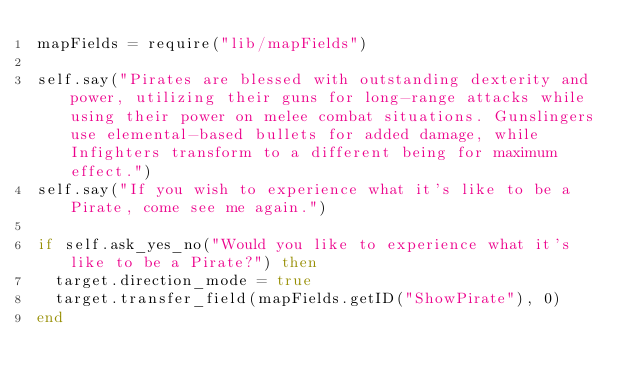Convert code to text. <code><loc_0><loc_0><loc_500><loc_500><_Lua_>mapFields = require("lib/mapFields")

self.say("Pirates are blessed with outstanding dexterity and power, utilizing their guns for long-range attacks while using their power on melee combat situations. Gunslingers use elemental-based bullets for added damage, while Infighters transform to a different being for maximum effect.")
self.say("If you wish to experience what it's like to be a Pirate, come see me again.")

if self.ask_yes_no("Would you like to experience what it's like to be a Pirate?") then
	target.direction_mode = true
	target.transfer_field(mapFields.getID("ShowPirate"), 0)
end</code> 